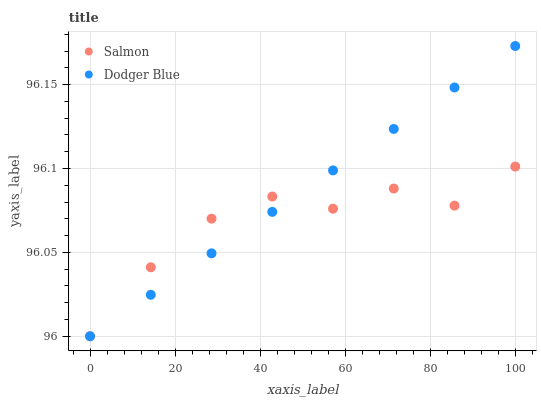Does Salmon have the minimum area under the curve?
Answer yes or no. Yes. Does Dodger Blue have the maximum area under the curve?
Answer yes or no. Yes. Does Salmon have the maximum area under the curve?
Answer yes or no. No. Is Dodger Blue the smoothest?
Answer yes or no. Yes. Is Salmon the roughest?
Answer yes or no. Yes. Is Salmon the smoothest?
Answer yes or no. No. Does Dodger Blue have the lowest value?
Answer yes or no. Yes. Does Dodger Blue have the highest value?
Answer yes or no. Yes. Does Salmon have the highest value?
Answer yes or no. No. Does Dodger Blue intersect Salmon?
Answer yes or no. Yes. Is Dodger Blue less than Salmon?
Answer yes or no. No. Is Dodger Blue greater than Salmon?
Answer yes or no. No. 